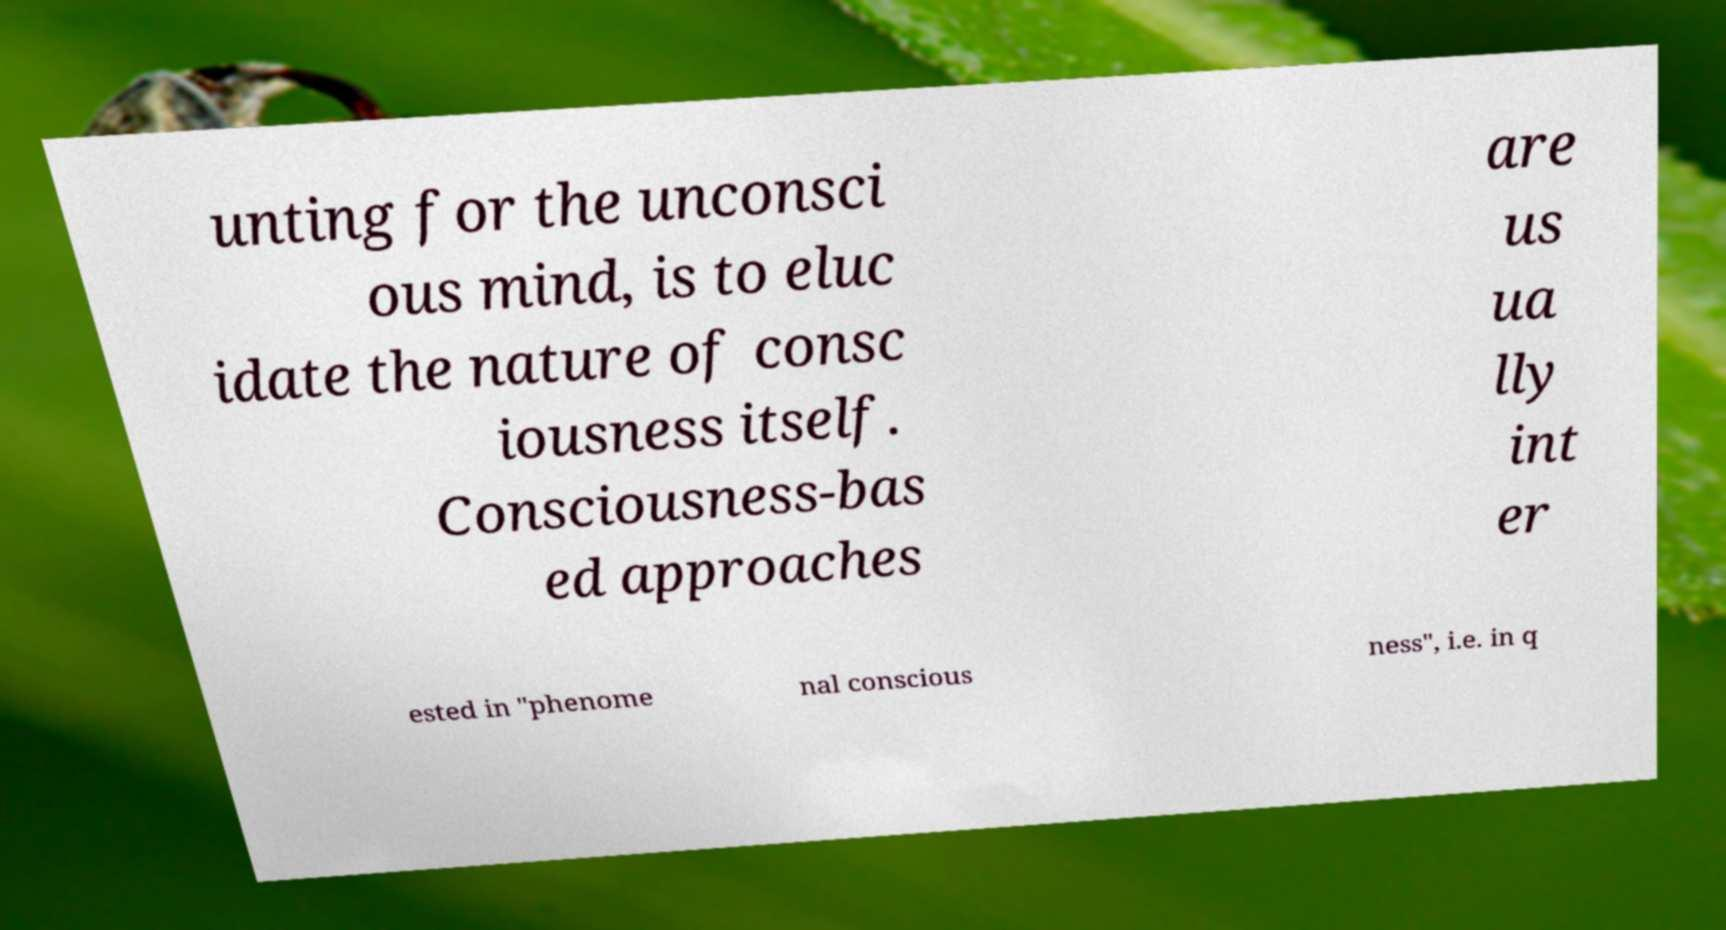Could you extract and type out the text from this image? unting for the unconsci ous mind, is to eluc idate the nature of consc iousness itself. Consciousness-bas ed approaches are us ua lly int er ested in "phenome nal conscious ness", i.e. in q 